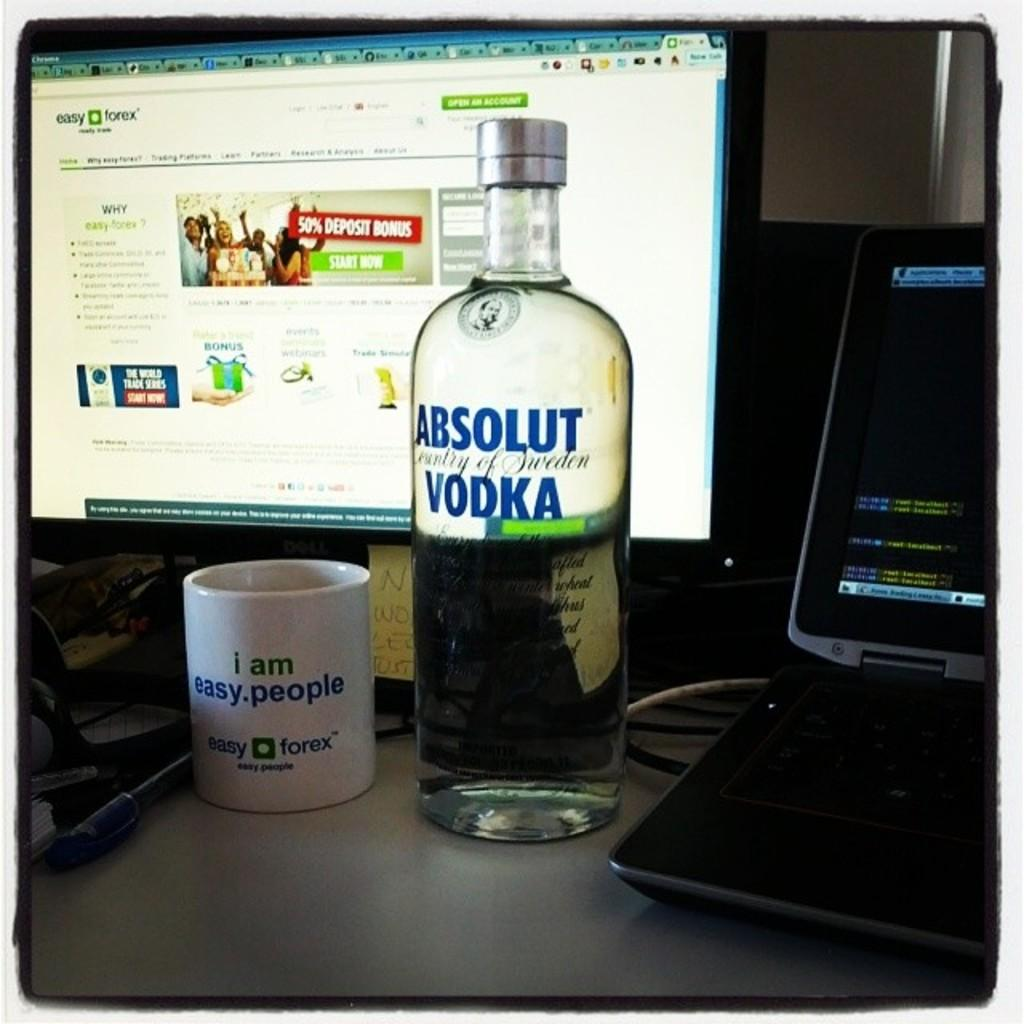What type of furniture is present in the image? There is a table in the image. What electronic device is on the table? There is a monitor on the table. What type of alcoholic beverage is visible on the table? There is a vodka bottle on the table. What is used for holding liquids on the table? There is a cup on the table. What other electronic device is on the table? There is a laptop on the table. What type of wool is being spun on the table in the image? There is no wool or spinning activity present in the image; it features a table with various electronic devices and a vodka bottle. What type of trees can be seen through the window in the image? There is no window or trees visible in the image; it only shows a table with various items on it. 